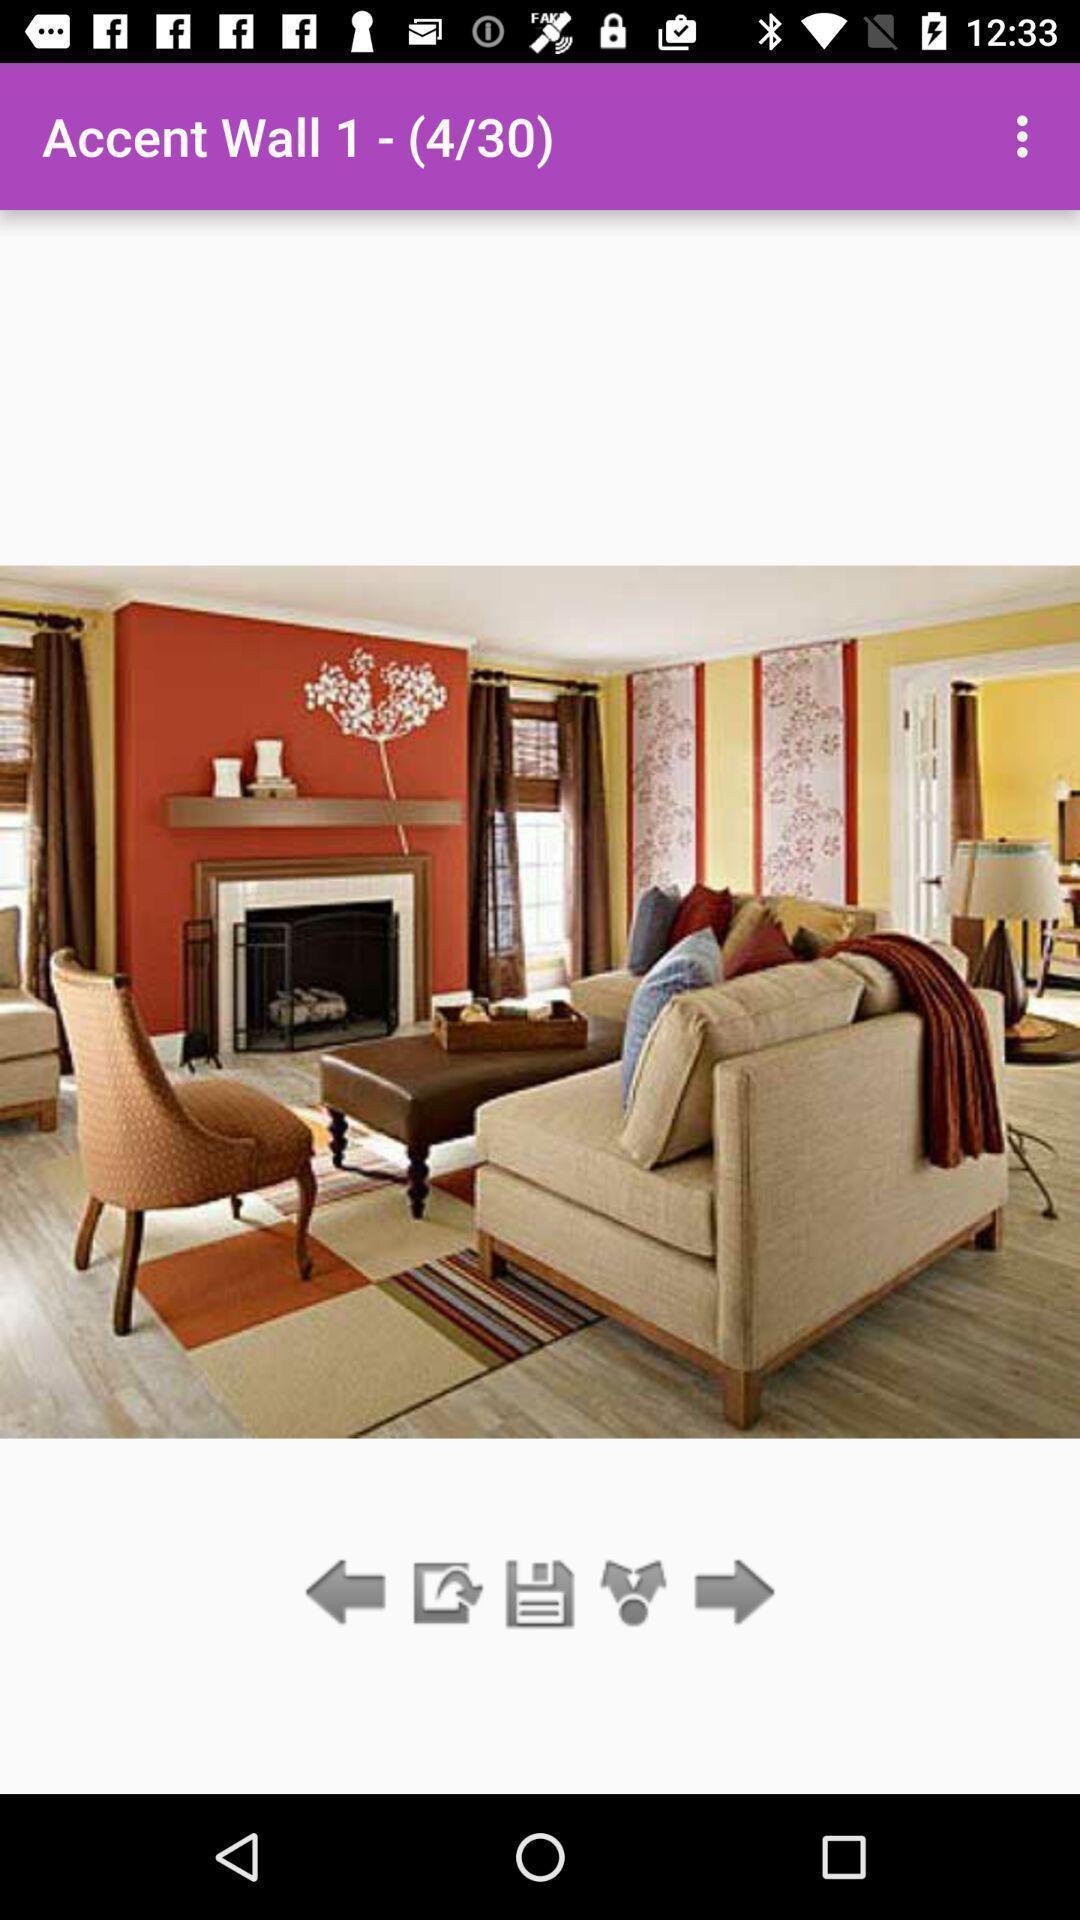What can you discern from this picture? Page showing image of wall decorated on an app. 